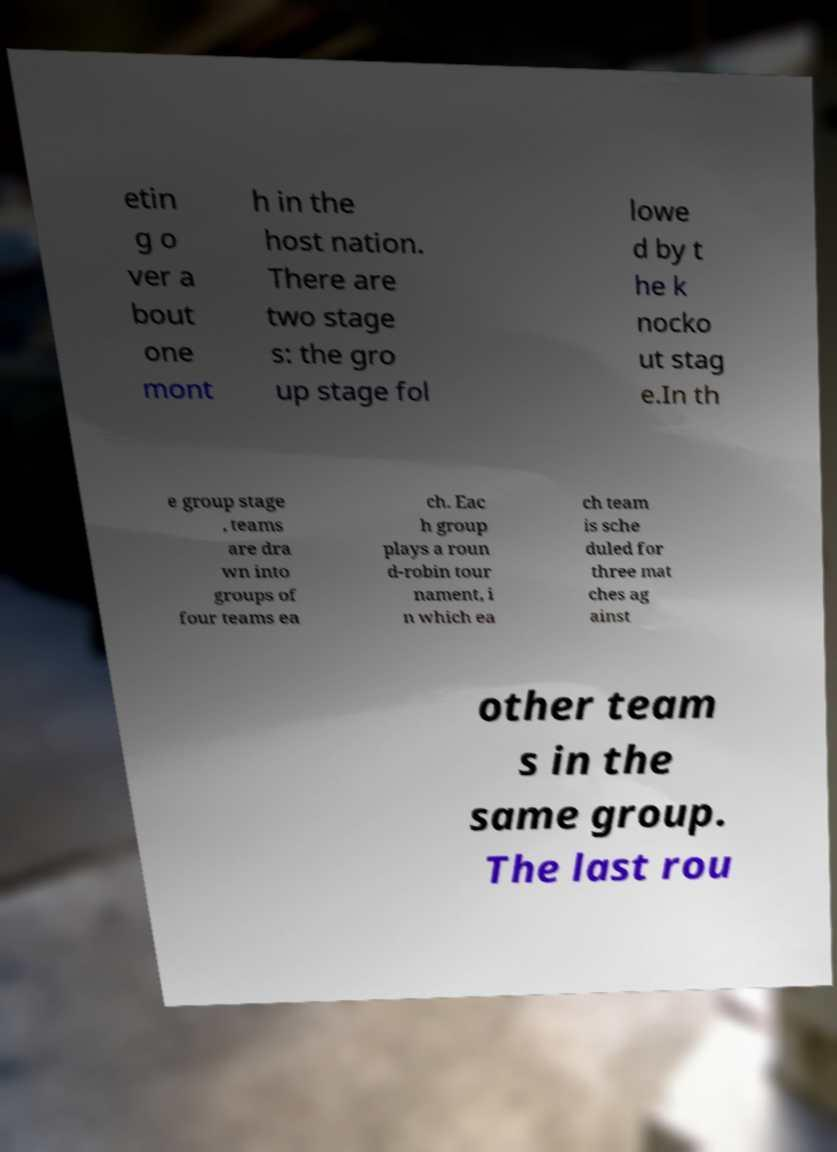Please identify and transcribe the text found in this image. etin g o ver a bout one mont h in the host nation. There are two stage s: the gro up stage fol lowe d by t he k nocko ut stag e.In th e group stage , teams are dra wn into groups of four teams ea ch. Eac h group plays a roun d-robin tour nament, i n which ea ch team is sche duled for three mat ches ag ainst other team s in the same group. The last rou 